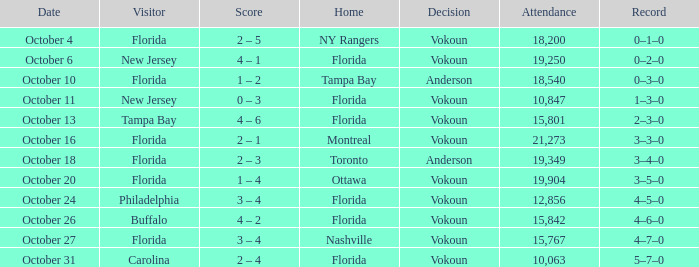What was the score on October 13? 4 – 6. 